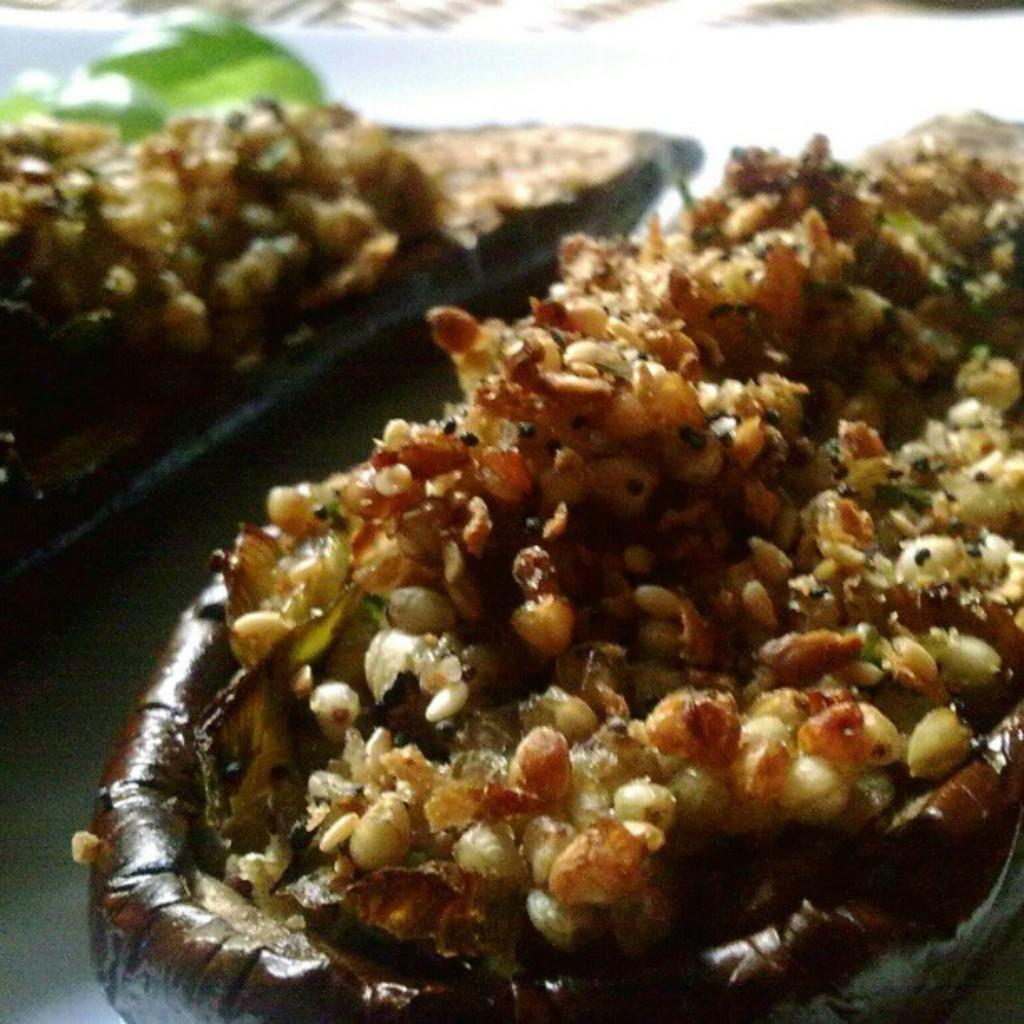What type of items can be seen in the image? There are food items in the image. Where are the food items located? The food items are on a surface. What type of range can be seen in the image? There is no range present in the image. What kind of pet is visible in the image? There are no pets visible in the image. Are there any bears present in the image? There are no bears present in the image. 